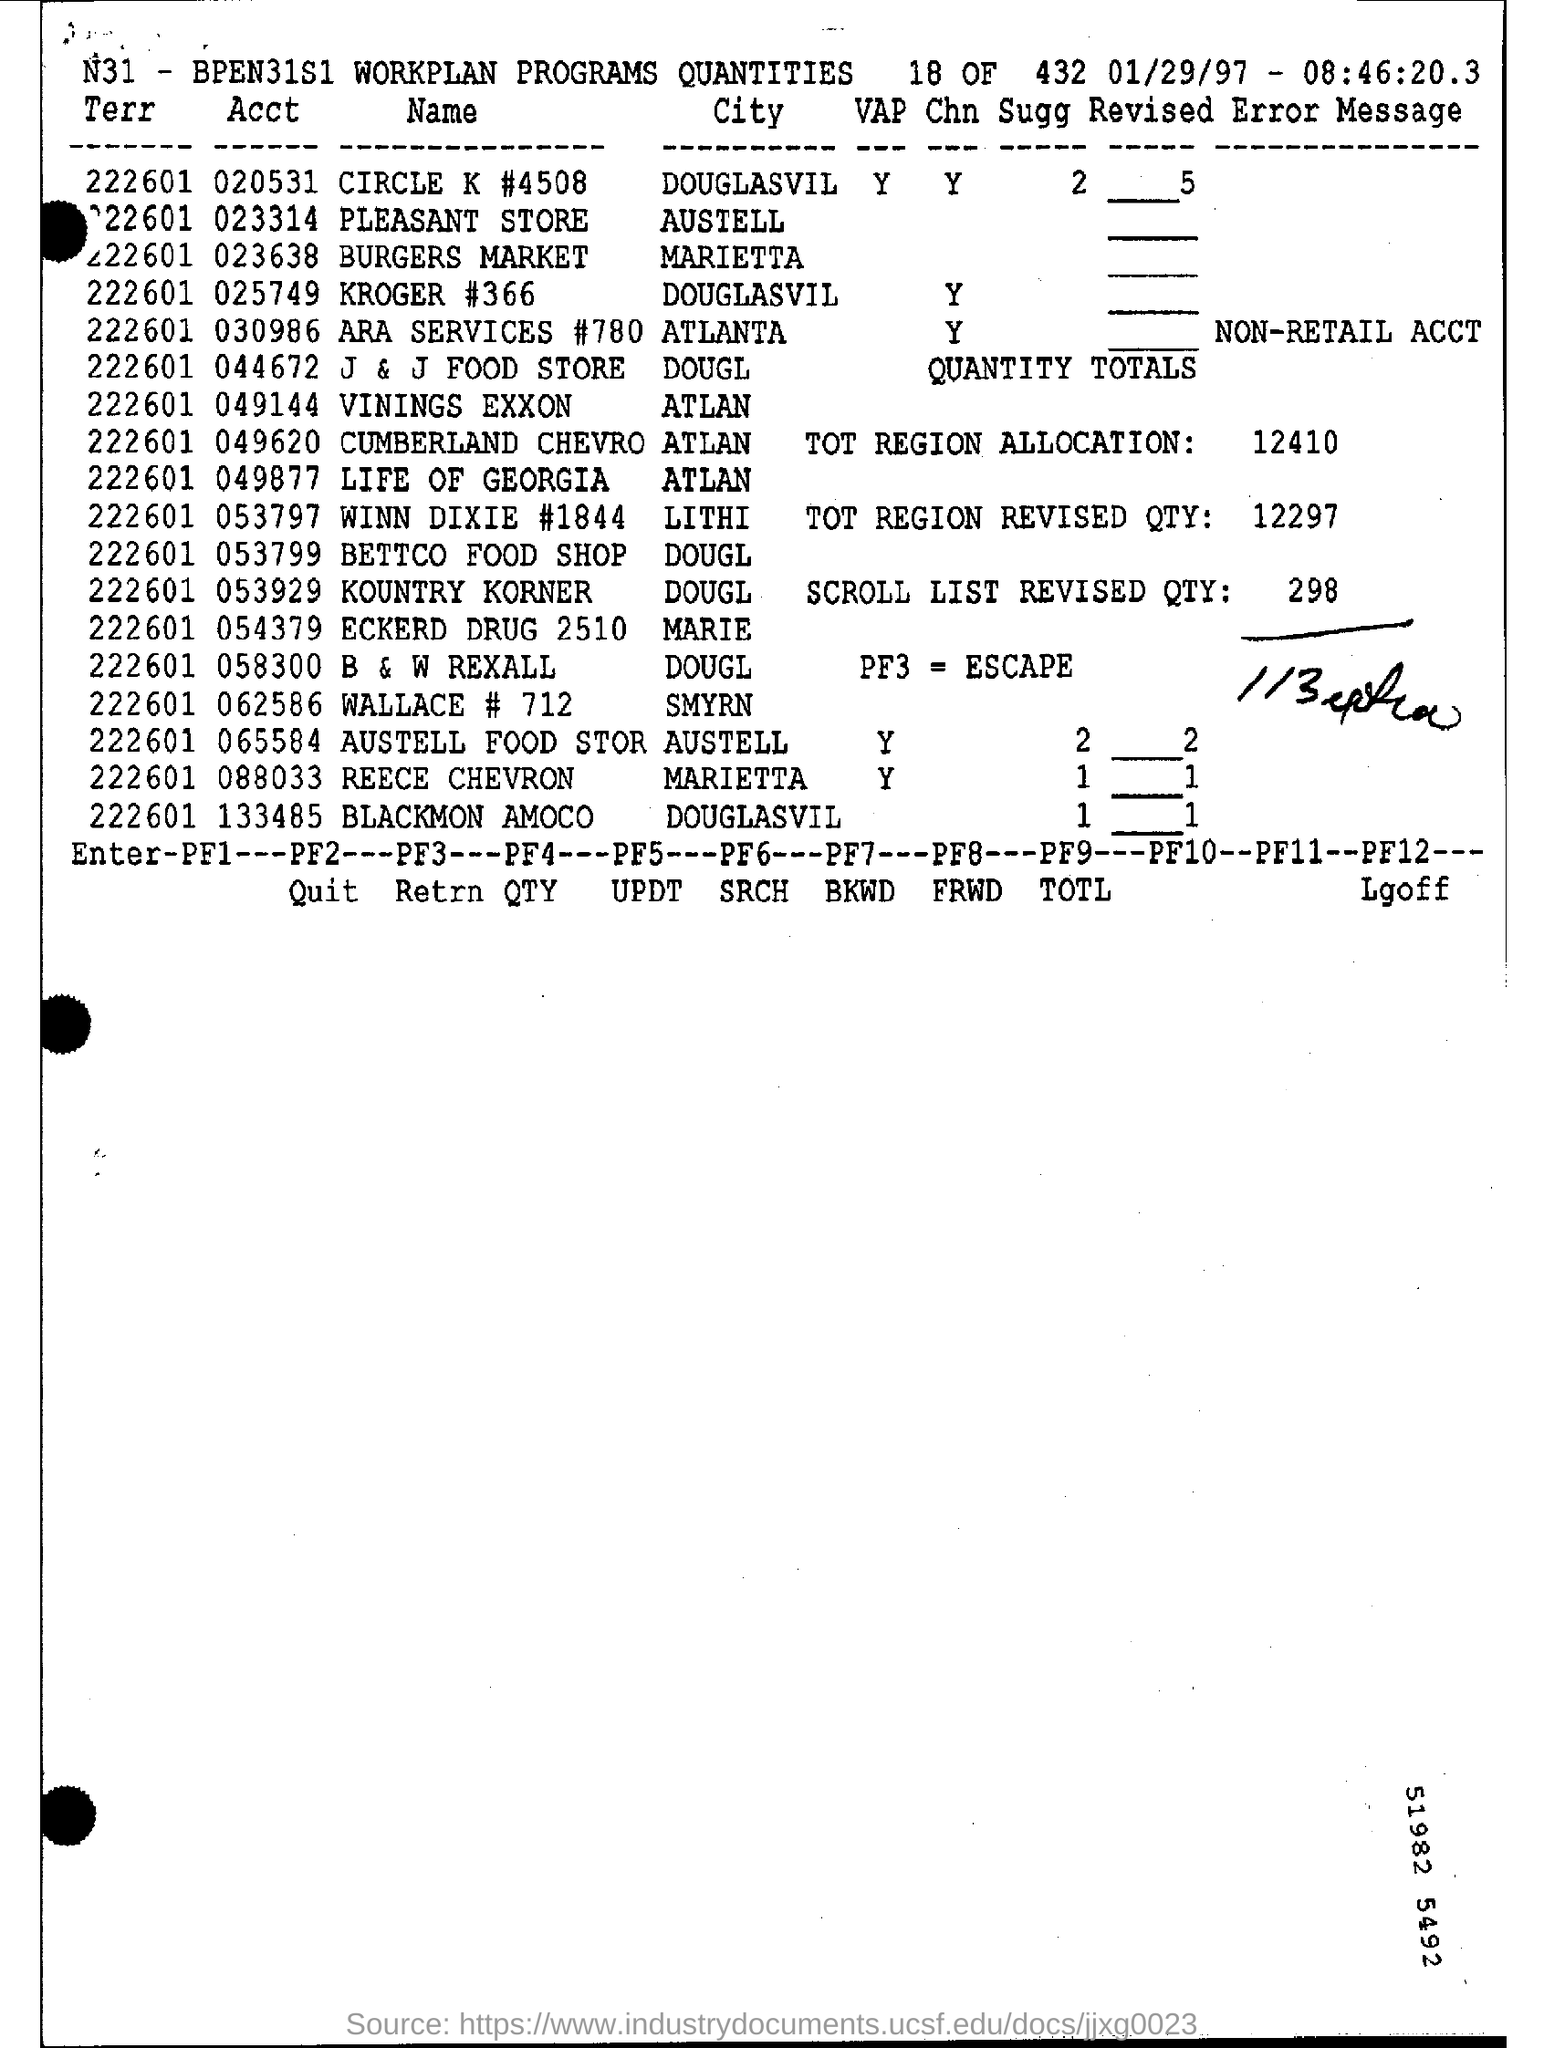How much is the scroll list revised qty ?
Your response must be concise. 298. What is the tot region allocation ?
Your answer should be very brief. 12410. In which city is pleasant store at ?
Make the answer very short. Austell. What is pf3 =?
Ensure brevity in your answer.  Escape. What is the date mentioned at the top of the page?
Provide a short and direct response. 01/29/97. What is acct of burgers market ?
Keep it short and to the point. 023638. 